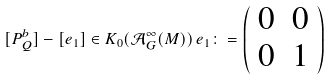<formula> <loc_0><loc_0><loc_500><loc_500>[ P ^ { b } _ { Q } ] - [ e _ { 1 } ] \in K _ { 0 } ( \mathcal { A } ^ { \infty } _ { G } ( M ) ) \, e _ { 1 } \colon = \left ( \begin{array} { c c } 0 & 0 \\ 0 & 1 \end{array} \right )</formula> 